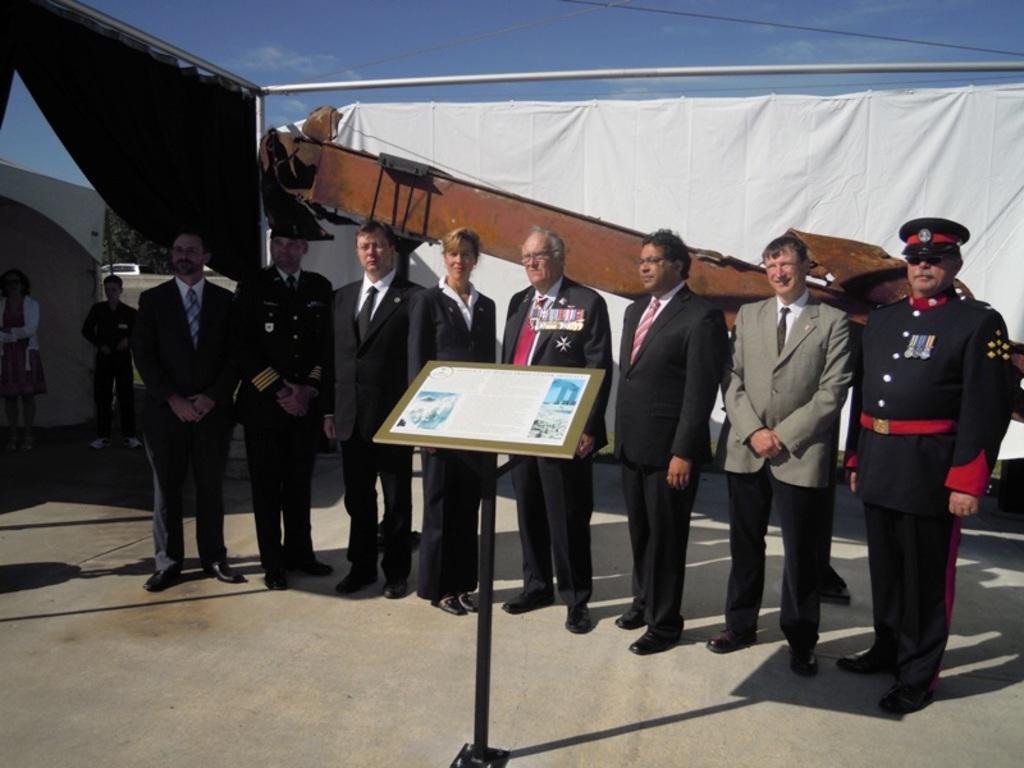Can you describe this image briefly? There are people standing in the center of the image and a desk in front of them. There are people, curtains, wires, tree, vehicle and sky in the background area. 